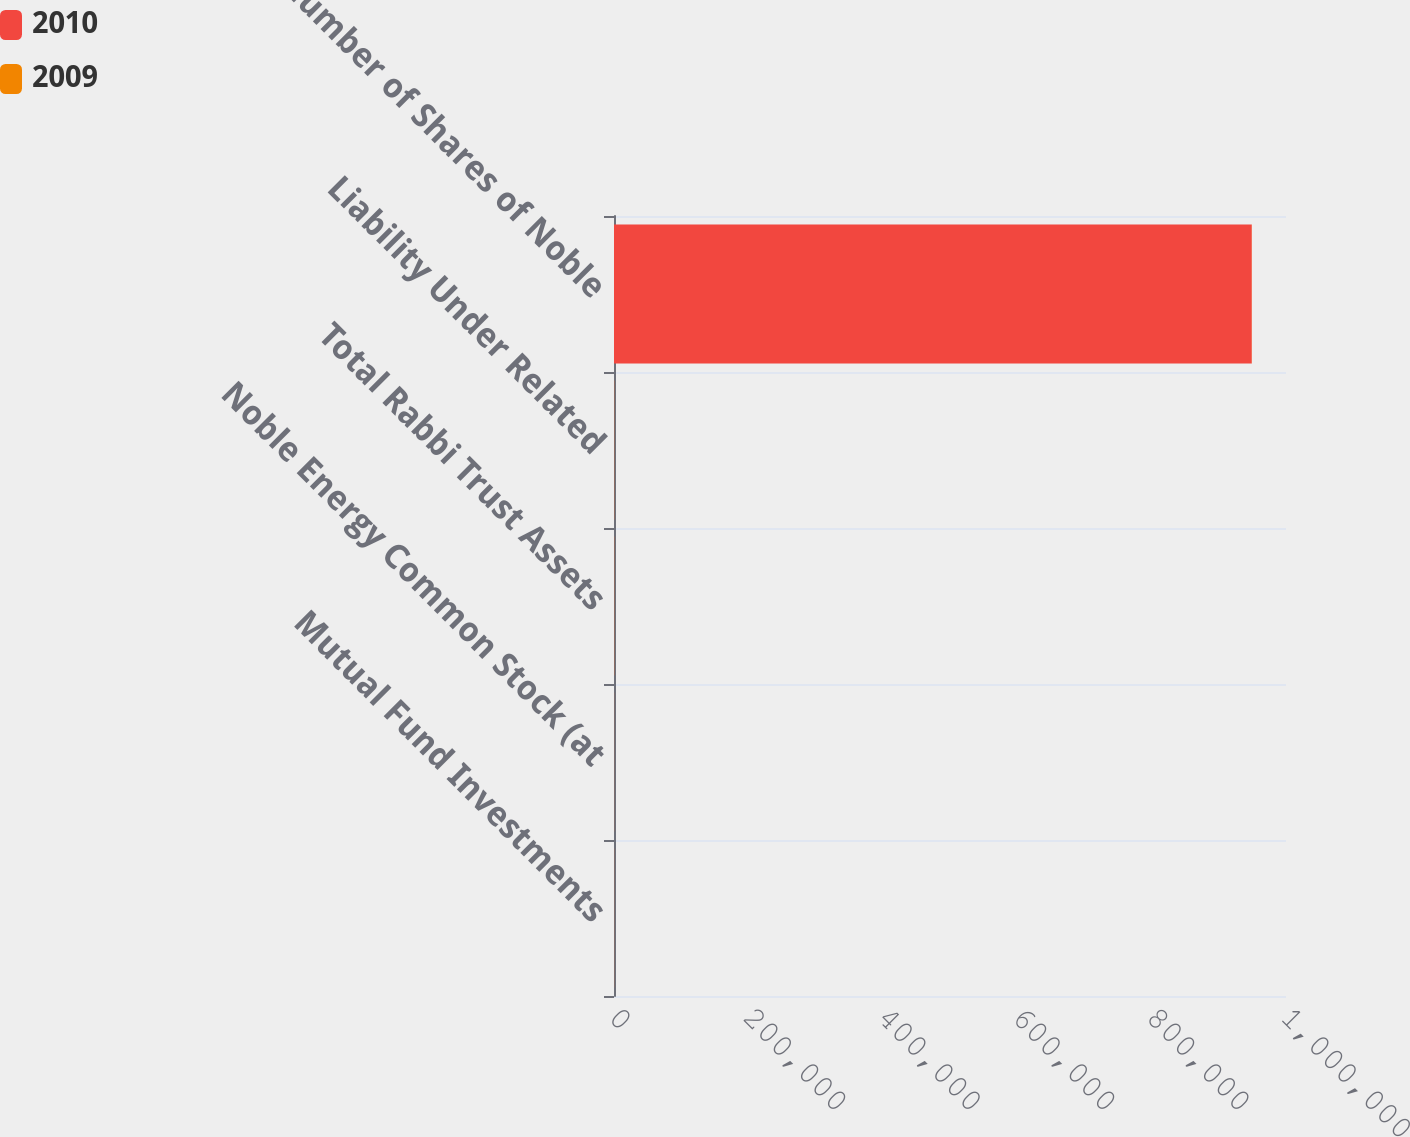Convert chart to OTSL. <chart><loc_0><loc_0><loc_500><loc_500><stacked_bar_chart><ecel><fcel>Mutual Fund Investments<fcel>Noble Energy Common Stock (at<fcel>Total Rabbi Trust Assets<fcel>Liability Under Related<fcel>Number of Shares of Noble<nl><fcel>2010<fcel>96<fcel>82<fcel>178<fcel>178<fcel>949040<nl><fcel>2009<fcel>93<fcel>75<fcel>168<fcel>168<fcel>168<nl></chart> 